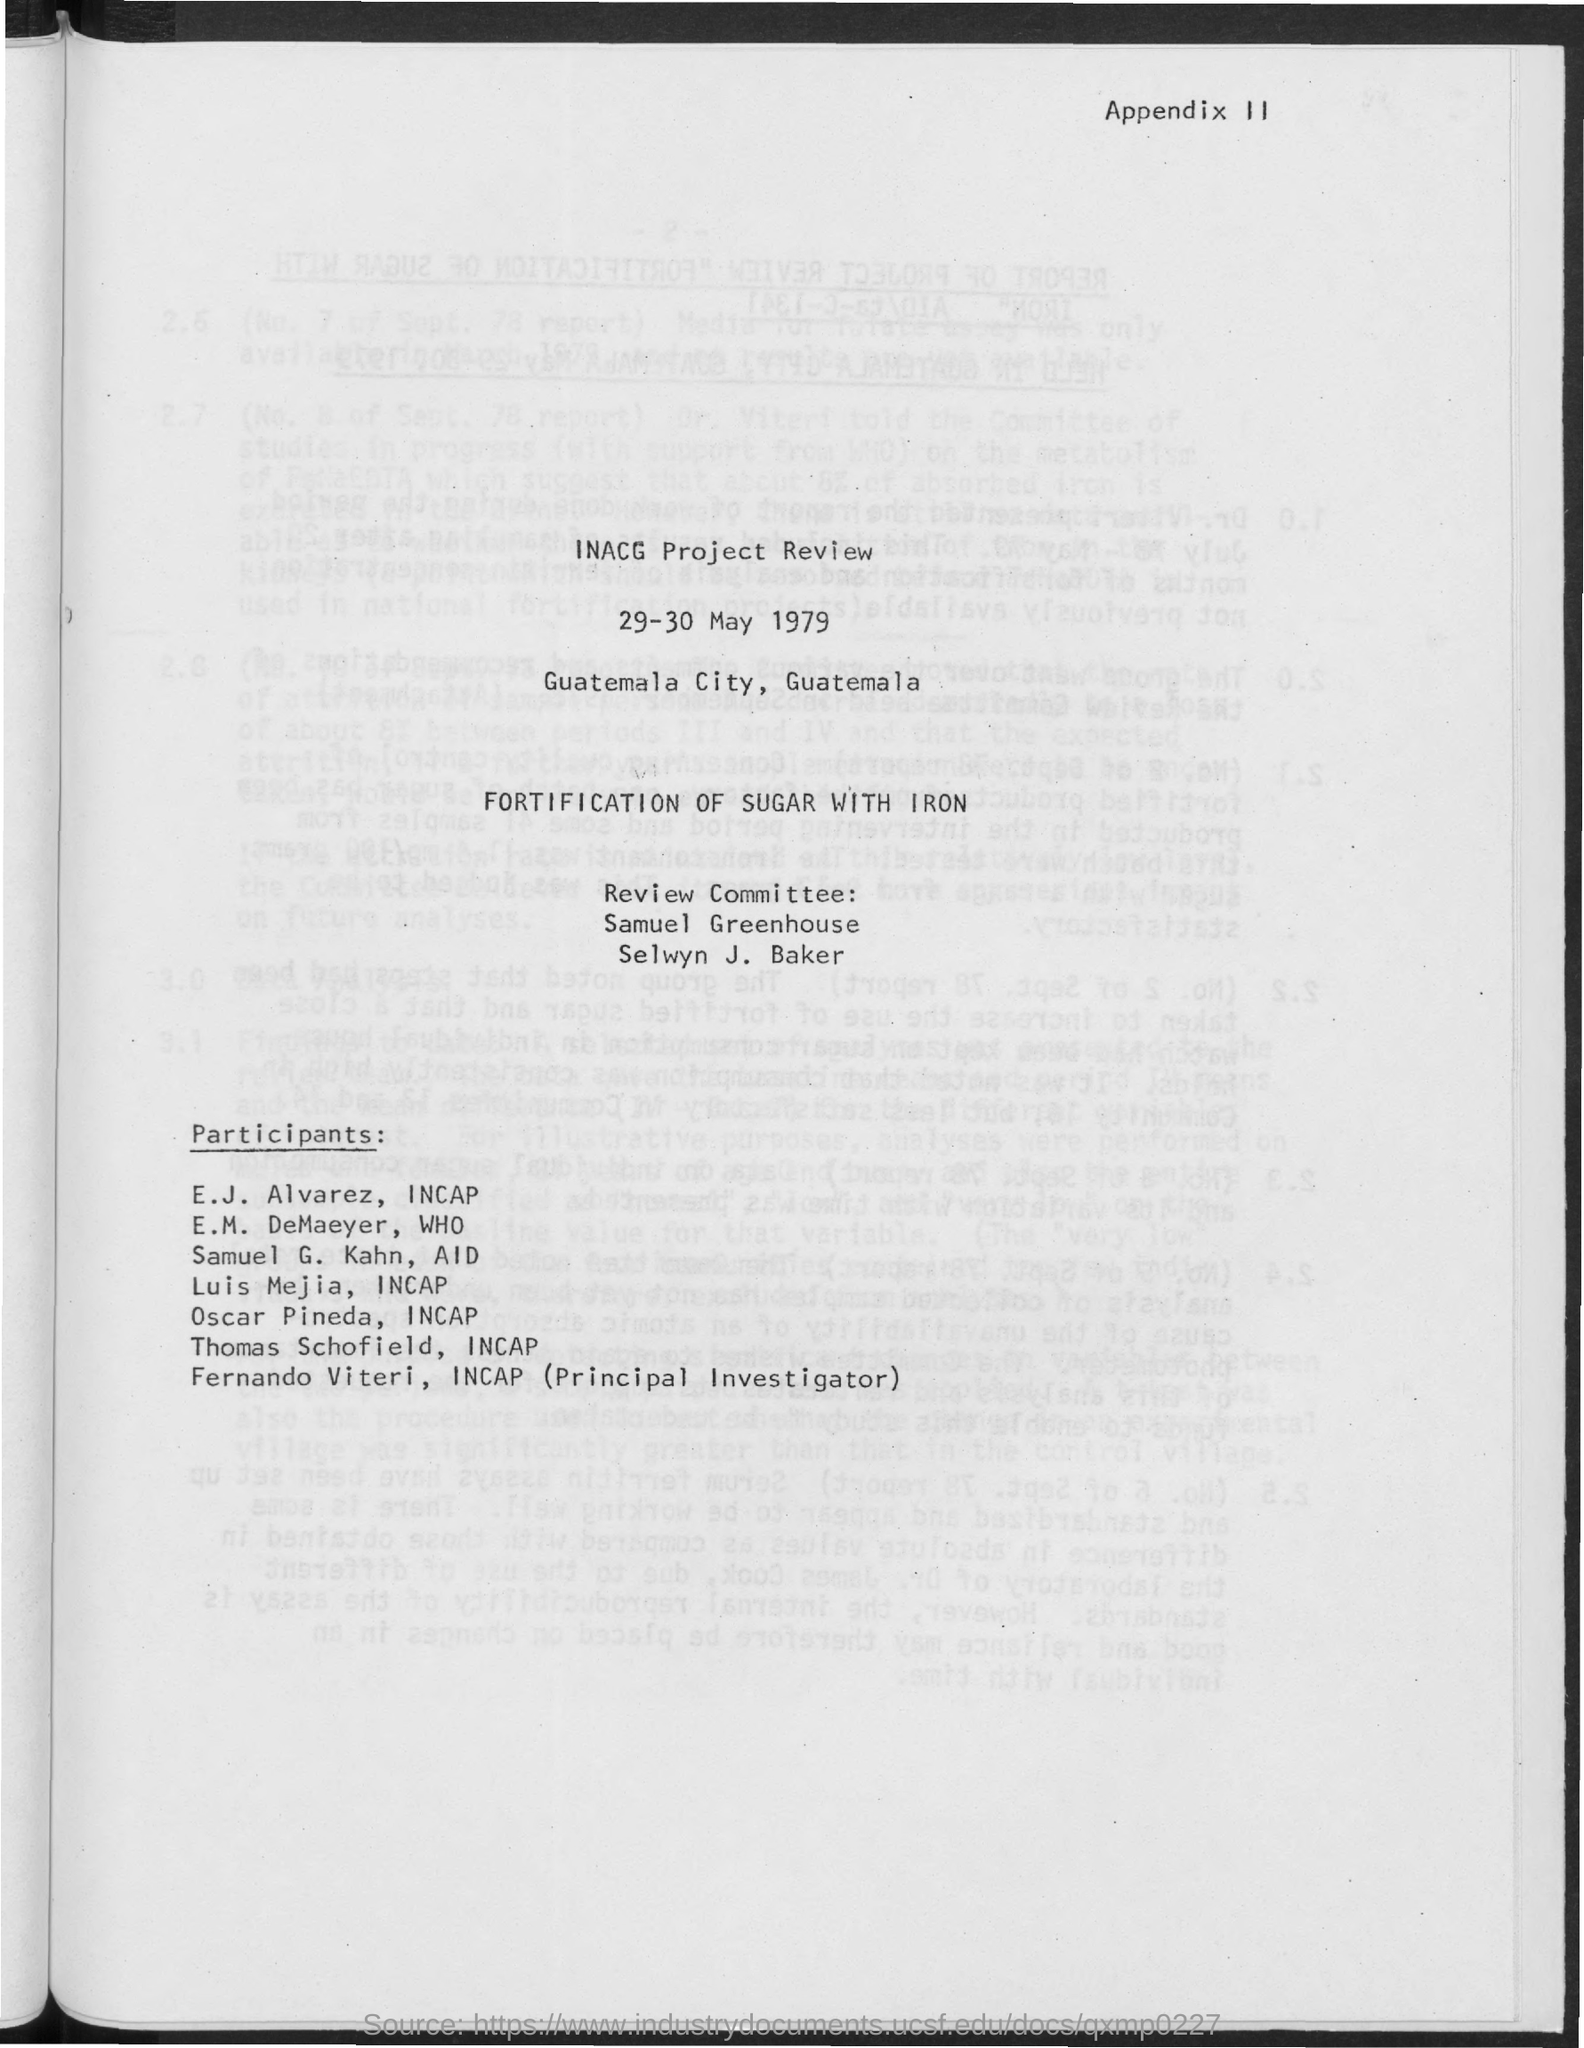Indicate a few pertinent items in this graphic. The principal investigator is Fernando Viteri. The document's first title is INACG Project Review. The document mentions that the date is 29-30 May 1979. Luis Mejia is a member of the INCAP organization. Samuel G. Kahn is a member of the organization known as AID. 